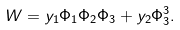Convert formula to latex. <formula><loc_0><loc_0><loc_500><loc_500>W = y _ { 1 } \Phi _ { 1 } \Phi _ { 2 } \Phi _ { 3 } + y _ { 2 } \Phi _ { 3 } ^ { 3 } .</formula> 